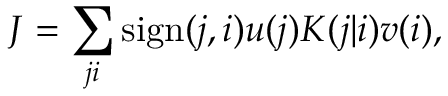Convert formula to latex. <formula><loc_0><loc_0><loc_500><loc_500>J = \sum _ { j i } s i g n ( j , i ) u ( j ) K ( j | i ) v ( i ) ,</formula> 